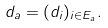<formula> <loc_0><loc_0><loc_500><loc_500>d _ { a } = ( d _ { i } ) _ { i \in E _ { a } } .</formula> 